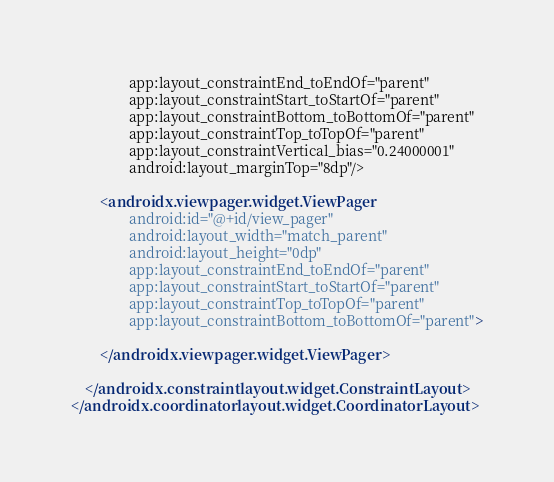Convert code to text. <code><loc_0><loc_0><loc_500><loc_500><_XML_>                app:layout_constraintEnd_toEndOf="parent"
                app:layout_constraintStart_toStartOf="parent"
                app:layout_constraintBottom_toBottomOf="parent"
                app:layout_constraintTop_toTopOf="parent"
                app:layout_constraintVertical_bias="0.24000001"
                android:layout_marginTop="8dp"/>

        <androidx.viewpager.widget.ViewPager
                android:id="@+id/view_pager"
                android:layout_width="match_parent"
                android:layout_height="0dp"
                app:layout_constraintEnd_toEndOf="parent"
                app:layout_constraintStart_toStartOf="parent"
                app:layout_constraintTop_toTopOf="parent"
                app:layout_constraintBottom_toBottomOf="parent">

        </androidx.viewpager.widget.ViewPager>

    </androidx.constraintlayout.widget.ConstraintLayout>
</androidx.coordinatorlayout.widget.CoordinatorLayout></code> 